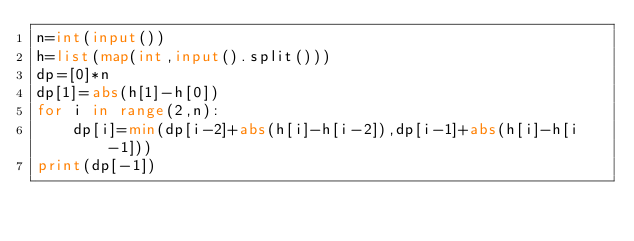Convert code to text. <code><loc_0><loc_0><loc_500><loc_500><_Python_>n=int(input())
h=list(map(int,input().split()))
dp=[0]*n 
dp[1]=abs(h[1]-h[0])
for i in range(2,n):
    dp[i]=min(dp[i-2]+abs(h[i]-h[i-2]),dp[i-1]+abs(h[i]-h[i-1]))
print(dp[-1])</code> 